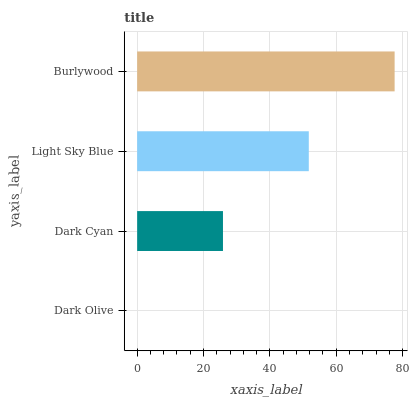Is Dark Olive the minimum?
Answer yes or no. Yes. Is Burlywood the maximum?
Answer yes or no. Yes. Is Dark Cyan the minimum?
Answer yes or no. No. Is Dark Cyan the maximum?
Answer yes or no. No. Is Dark Cyan greater than Dark Olive?
Answer yes or no. Yes. Is Dark Olive less than Dark Cyan?
Answer yes or no. Yes. Is Dark Olive greater than Dark Cyan?
Answer yes or no. No. Is Dark Cyan less than Dark Olive?
Answer yes or no. No. Is Light Sky Blue the high median?
Answer yes or no. Yes. Is Dark Cyan the low median?
Answer yes or no. Yes. Is Dark Cyan the high median?
Answer yes or no. No. Is Light Sky Blue the low median?
Answer yes or no. No. 